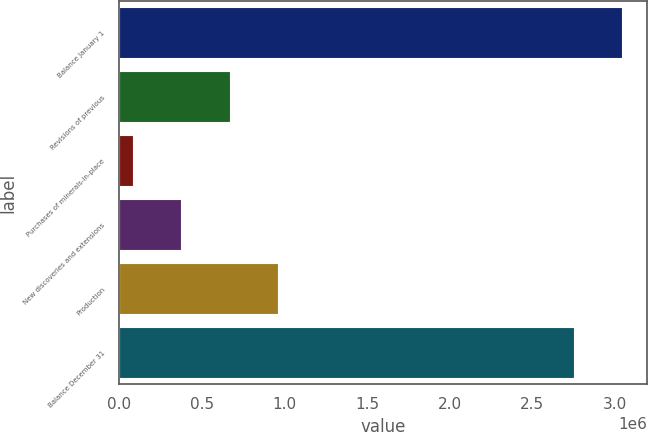Convert chart. <chart><loc_0><loc_0><loc_500><loc_500><bar_chart><fcel>Balance January 1<fcel>Revisions of previous<fcel>Purchases of minerals-in-place<fcel>New discoveries and extensions<fcel>Production<fcel>Balance December 31<nl><fcel>3.04257e+06<fcel>666610<fcel>83179<fcel>374895<fcel>958326<fcel>2.75086e+06<nl></chart> 